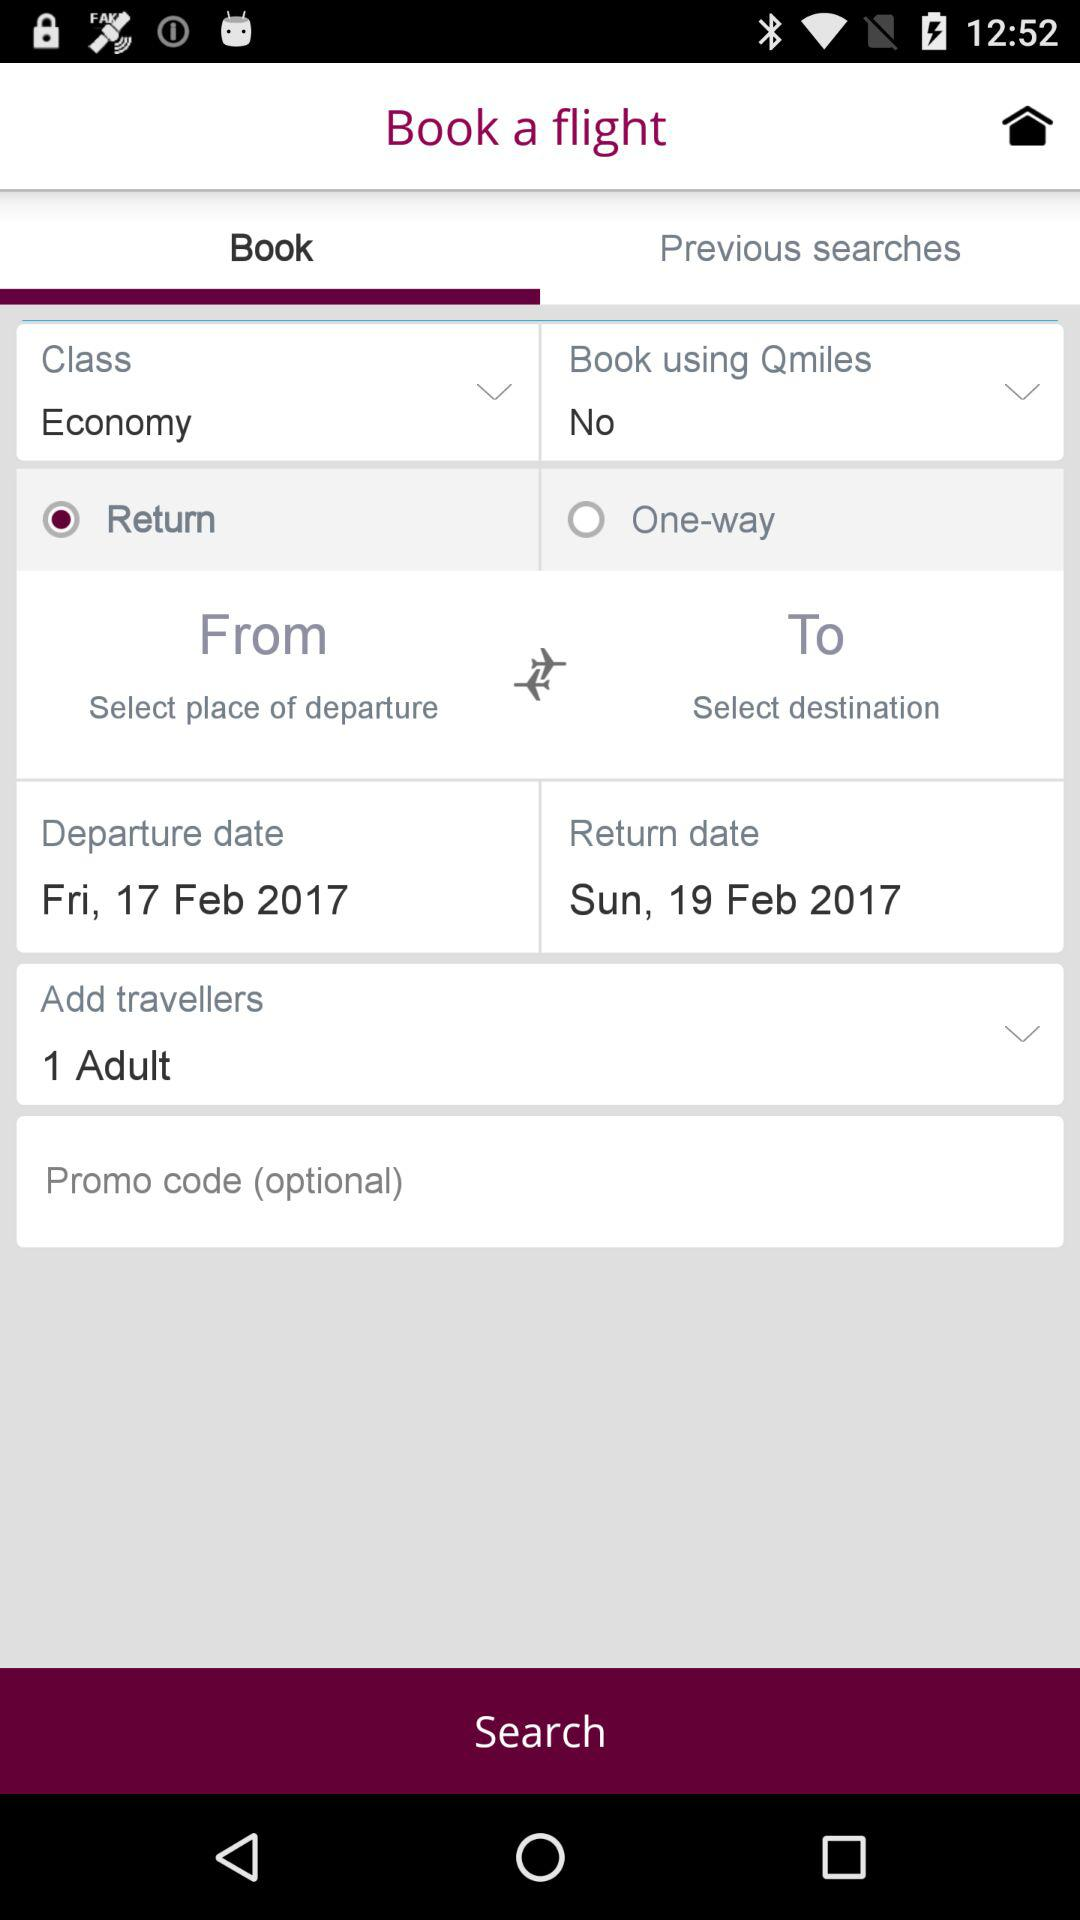How many adults are going to travel on the flight? There is 1 adult going to travel on the flight. 